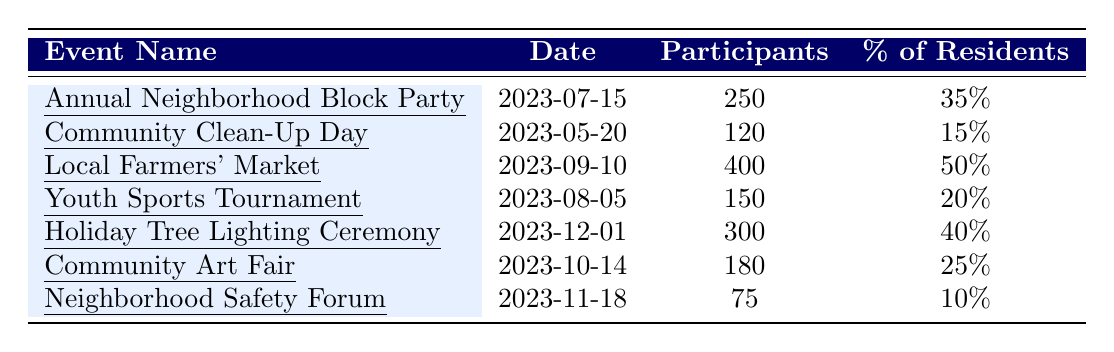What was the date of the Local Farmers' Market? The date associated with the Local Farmers' Market is directly listed in the table under the "Date" column.
Answer: 2023-09-10 How many participants did the Neighborhood Safety Forum have? The number of participants for the Neighborhood Safety Forum is specified in the "Participants" column for that event.
Answer: 75 Which event had the highest participation rate as a percentage of residents? By looking at the "% of Residents" column, the Local Farmers' Market with 50% has the highest participation rate.
Answer: Local Farmers' Market What is the total number of participants across all events? To find the total participants, add the number of participants from each event: 250 + 120 + 400 + 150 + 300 + 180 + 75 = 1475.
Answer: 1475 What percentage of residents participated in the Holiday Tree Lighting Ceremony? The percentage of residents for the Holiday Tree Lighting Ceremony is listed under the "% of Residents" column.
Answer: 40% Which event included "Litter Collection" as one of its activities? The event that included "Litter Collection" in its activities, as listed, is the Community Clean-Up Day.
Answer: Community Clean-Up Day What is the average participation rate of all events? To find the average, sum the percentages: (35 + 15 + 50 + 20 + 40 + 25 + 10) = 195, then divide by the number of events (7): 195/7 = 27.857.
Answer: 27.86% Was the Community Art Fair more popular than the Community Clean-Up Day in terms of participants? The Community Art Fair had 180 participants while the Community Clean-Up Day had 120 participants, indicating that the Community Art Fair was more popular.
Answer: Yes How many events took place in the second half of the year? The events held from July to December are: Annual Neighborhood Block Party, Local Farmers' Market, Holiday Tree Lighting Ceremony, Community Art Fair, and Neighborhood Safety Forum, totaling 5 events.
Answer: 5 What is the difference in participant numbers between the Annual Neighborhood Block Party and the Youth Sports Tournament? Subtract the number of participants in the Youth Sports Tournament (150) from the Annual Neighborhood Block Party (250): 250 - 150 = 100.
Answer: 100 